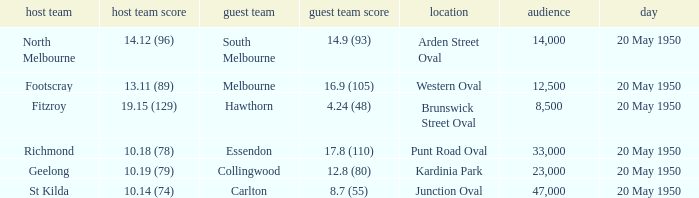What was the score for the away team that played against Richmond and has a crowd over 12,500? 17.8 (110). 